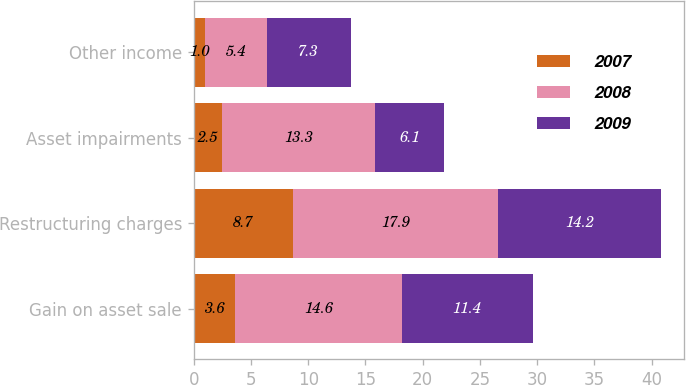<chart> <loc_0><loc_0><loc_500><loc_500><stacked_bar_chart><ecel><fcel>Gain on asset sale<fcel>Restructuring charges<fcel>Asset impairments<fcel>Other income<nl><fcel>2007<fcel>3.6<fcel>8.7<fcel>2.5<fcel>1<nl><fcel>2008<fcel>14.6<fcel>17.9<fcel>13.3<fcel>5.4<nl><fcel>2009<fcel>11.4<fcel>14.2<fcel>6.1<fcel>7.3<nl></chart> 